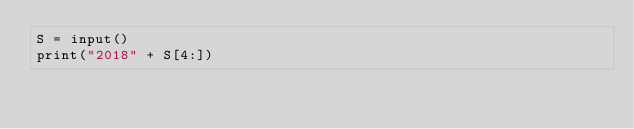Convert code to text. <code><loc_0><loc_0><loc_500><loc_500><_Python_>S = input()
print("2018" + S[4:])
</code> 